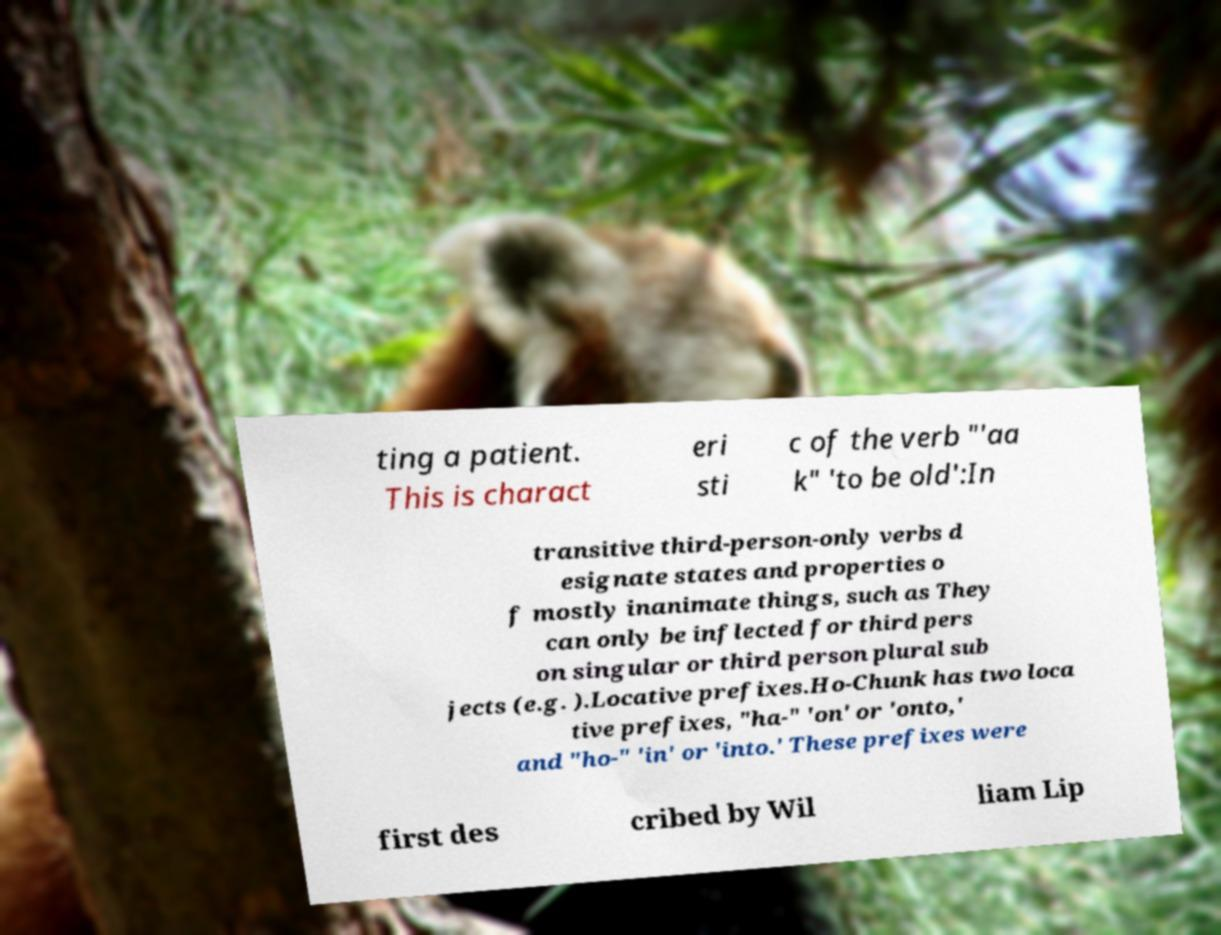Can you accurately transcribe the text from the provided image for me? ting a patient. This is charact eri sti c of the verb "'aa k" 'to be old':In transitive third-person-only verbs d esignate states and properties o f mostly inanimate things, such as They can only be inflected for third pers on singular or third person plural sub jects (e.g. ).Locative prefixes.Ho-Chunk has two loca tive prefixes, "ha-" 'on' or 'onto,' and "ho-" 'in' or 'into.' These prefixes were first des cribed by Wil liam Lip 